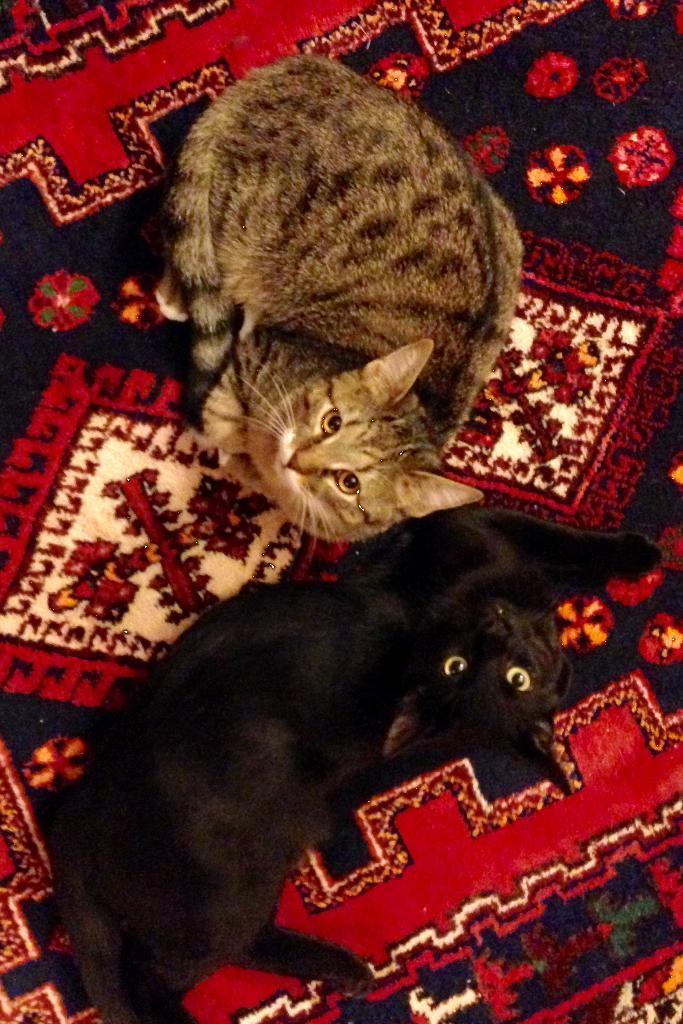What is present on the bed in the image? There is a bed sheet in the image. What animals can be seen in the image? There are two cats in the image. Can you describe the appearance of the cats? One cat is black in color, and the other cat has cream and black dots on it. What are the cats doing in the image? Both cats are sitting and looking up. What type of crown is the cat wearing in the image? There is no crown present in the image; the cats are not wearing any accessories. 